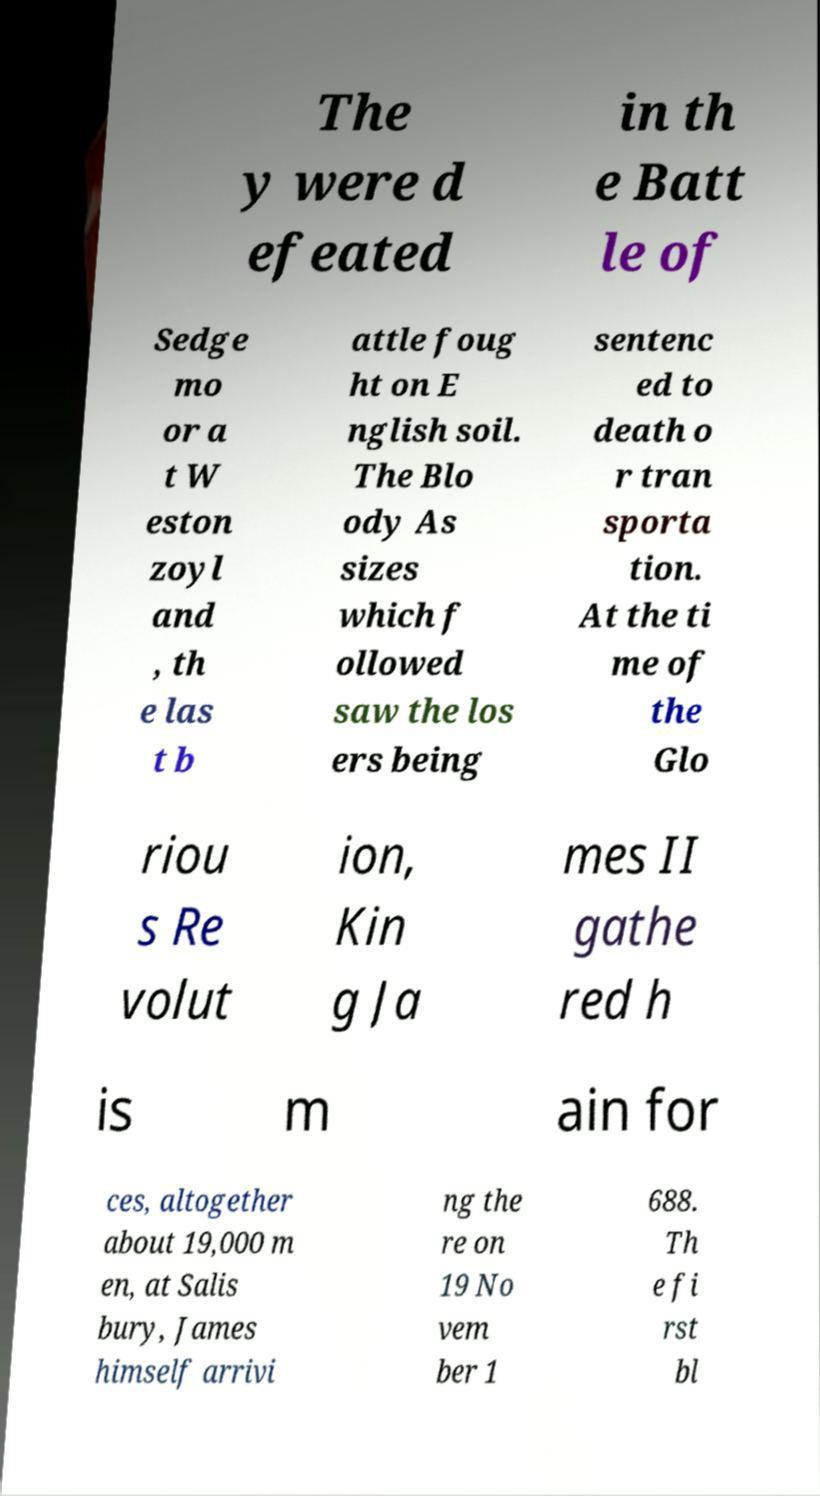Can you read and provide the text displayed in the image?This photo seems to have some interesting text. Can you extract and type it out for me? The y were d efeated in th e Batt le of Sedge mo or a t W eston zoyl and , th e las t b attle foug ht on E nglish soil. The Blo ody As sizes which f ollowed saw the los ers being sentenc ed to death o r tran sporta tion. At the ti me of the Glo riou s Re volut ion, Kin g Ja mes II gathe red h is m ain for ces, altogether about 19,000 m en, at Salis bury, James himself arrivi ng the re on 19 No vem ber 1 688. Th e fi rst bl 